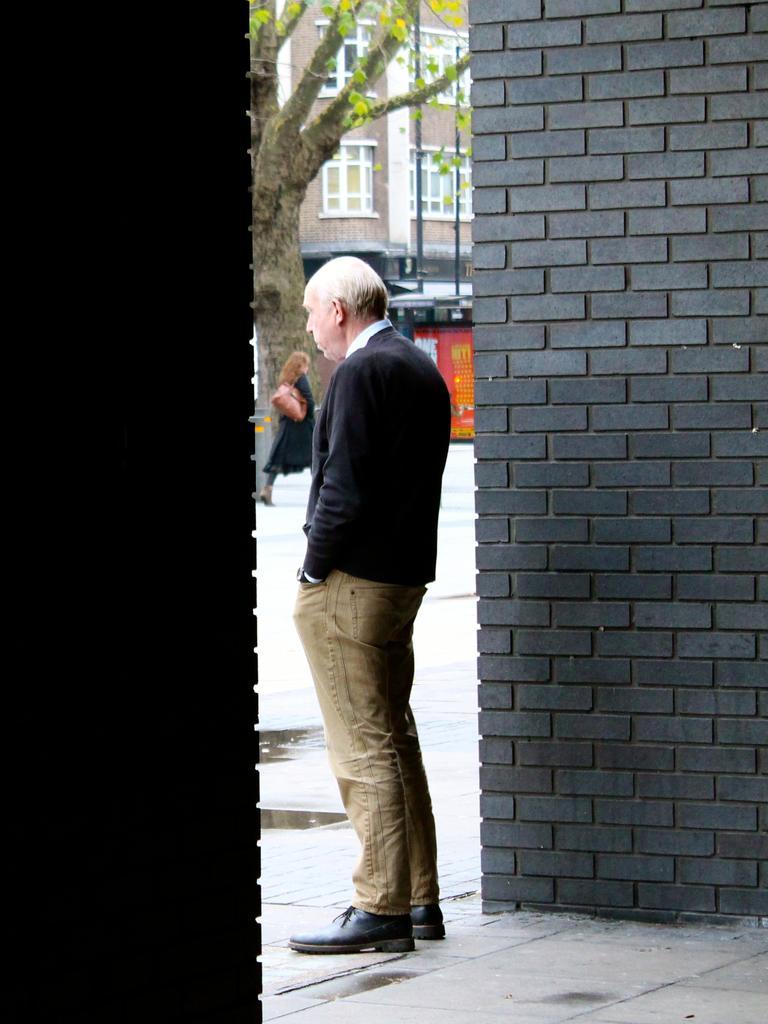Could you give a brief overview of what you see in this image? In the center of the image we can see a man is standing. On the left and right side of the image wall is there. At the bottom of the image floor is present. At the top of the image we can see a tree, building, shed, poles and a lady is walking and carrying a bag. In the middle of the image road is there. 